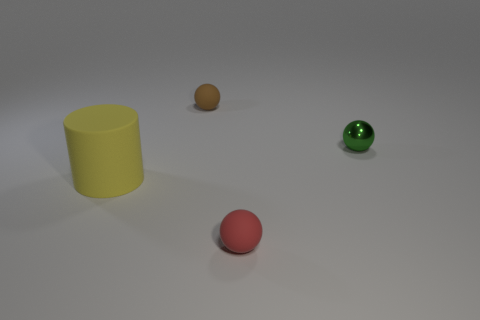Is there a pattern to the arrangement of these objects? The objects are arranged with an even distribution across the image, aligned approximately in the middle of the horizontal plane. They are placed with varying distances between them, creating a sense of casual, yet somewhat intentional placement, possibly to showcase their differing materials and shapes. Could the distances between the objects correlate to their sizes? It's an interesting observation, but there doesn't seem to be a direct correlation between the distances and their sizes in this arrangement. The spacing appears to be more aesthetically driven rather than size-proportionate. 